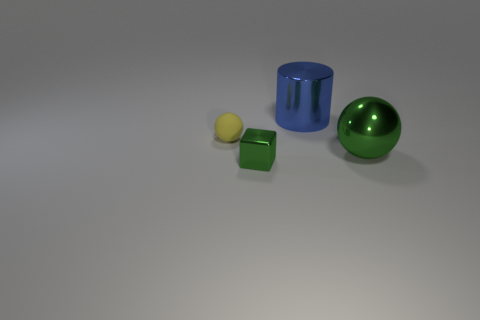There is a object that is in front of the green shiny object on the right side of the large metallic cylinder; what size is it?
Make the answer very short. Small. There is a object that is on the left side of the green shiny object that is in front of the green metal thing that is behind the green cube; what shape is it?
Keep it short and to the point. Sphere. Is the color of the thing that is left of the metallic cube the same as the large object behind the large green ball?
Your answer should be very brief. No. What color is the large thing that is right of the large metal object behind the sphere in front of the rubber thing?
Your answer should be very brief. Green. Do the big object that is in front of the blue metal object and the big object behind the yellow matte ball have the same material?
Offer a very short reply. Yes. How many objects are either large red metal cylinders or metal things left of the big ball?
Keep it short and to the point. 2. How many green objects are the same size as the blue shiny thing?
Keep it short and to the point. 1. Are there fewer large green metallic objects that are in front of the green metal cube than small objects that are behind the big blue cylinder?
Provide a succinct answer. No. How many metallic objects are either small yellow balls or small blue things?
Offer a terse response. 0. What is the shape of the small green metallic object?
Offer a very short reply. Cube. 